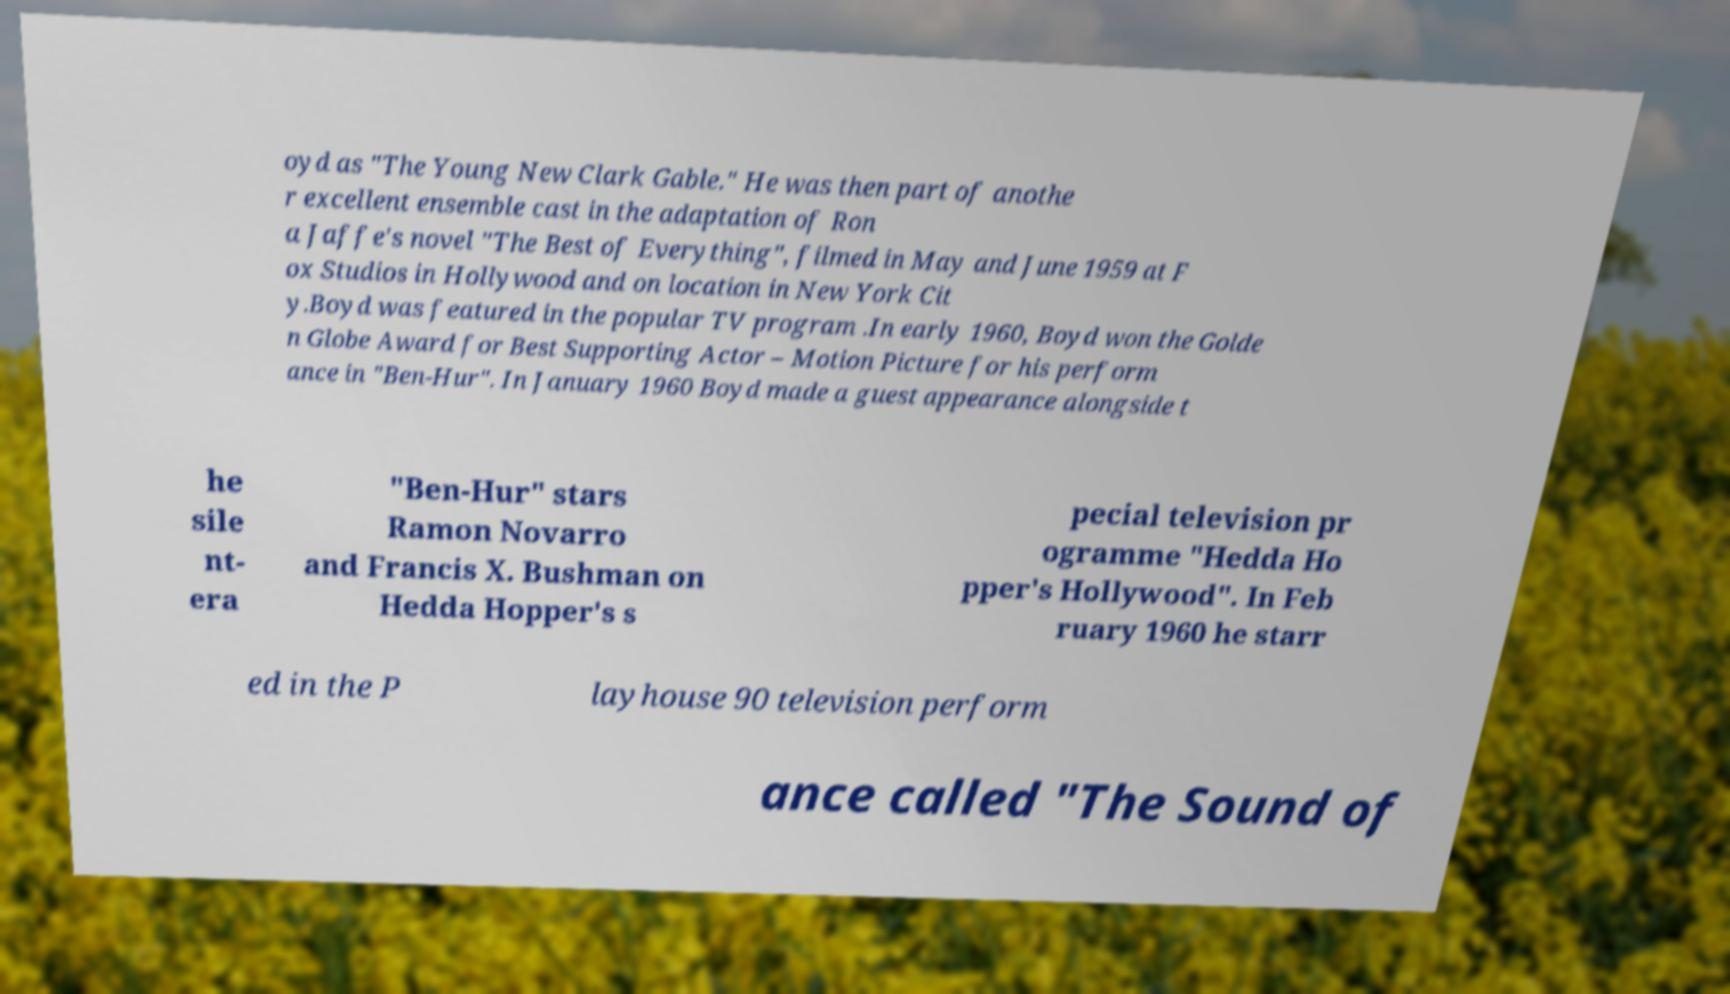Please read and relay the text visible in this image. What does it say? oyd as "The Young New Clark Gable." He was then part of anothe r excellent ensemble cast in the adaptation of Ron a Jaffe's novel "The Best of Everything", filmed in May and June 1959 at F ox Studios in Hollywood and on location in New York Cit y.Boyd was featured in the popular TV program .In early 1960, Boyd won the Golde n Globe Award for Best Supporting Actor – Motion Picture for his perform ance in "Ben-Hur". In January 1960 Boyd made a guest appearance alongside t he sile nt- era "Ben-Hur" stars Ramon Novarro and Francis X. Bushman on Hedda Hopper's s pecial television pr ogramme "Hedda Ho pper's Hollywood". In Feb ruary 1960 he starr ed in the P layhouse 90 television perform ance called "The Sound of 